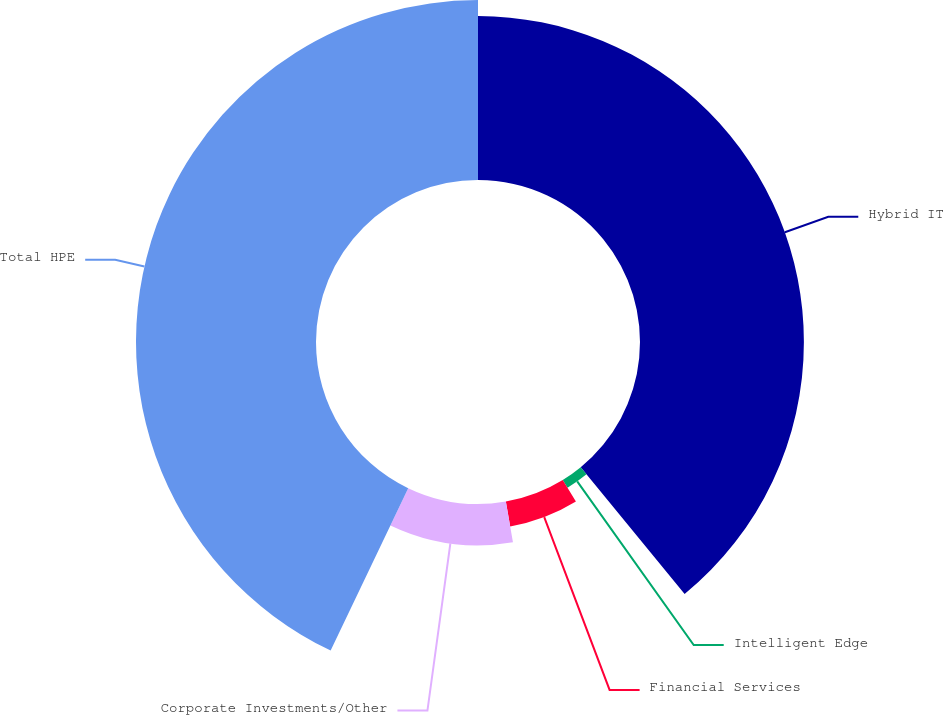Convert chart. <chart><loc_0><loc_0><loc_500><loc_500><pie_chart><fcel>Hybrid IT<fcel>Intelligent Edge<fcel>Financial Services<fcel>Corporate Investments/Other<fcel>Total HPE<nl><fcel>39.07%<fcel>2.17%<fcel>6.01%<fcel>9.84%<fcel>42.91%<nl></chart> 